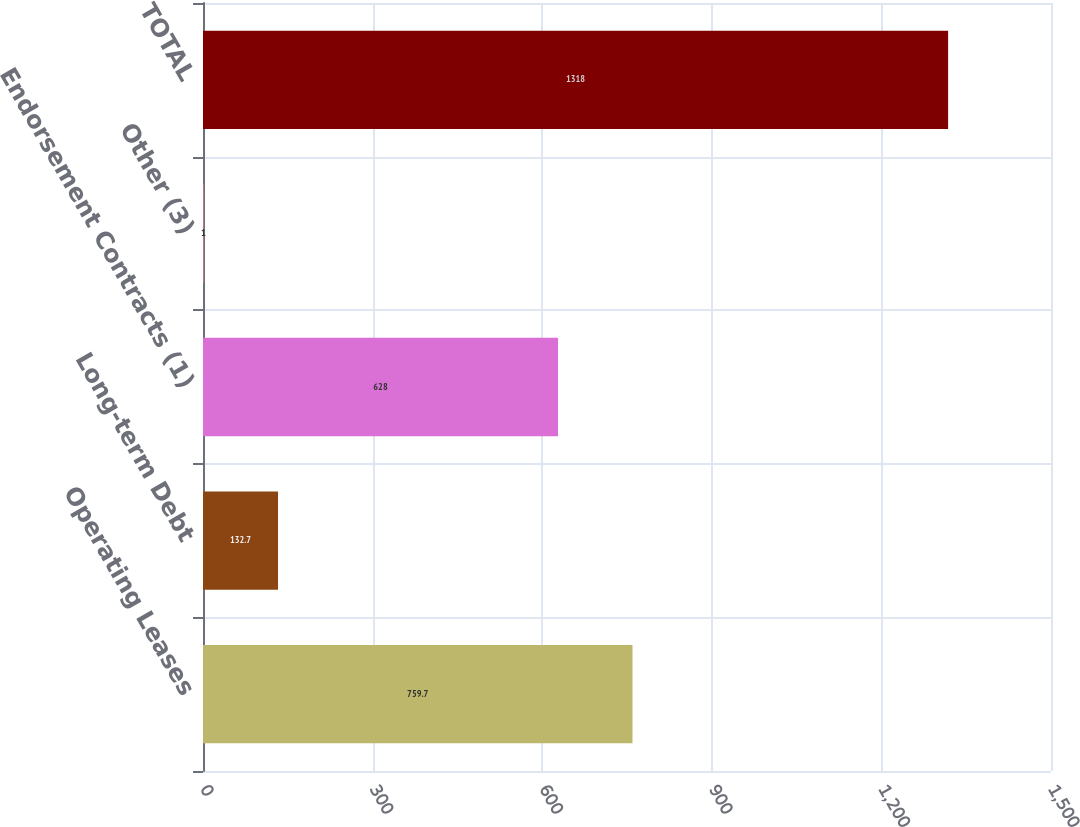Convert chart to OTSL. <chart><loc_0><loc_0><loc_500><loc_500><bar_chart><fcel>Operating Leases<fcel>Long-term Debt<fcel>Endorsement Contracts (1)<fcel>Other (3)<fcel>TOTAL<nl><fcel>759.7<fcel>132.7<fcel>628<fcel>1<fcel>1318<nl></chart> 